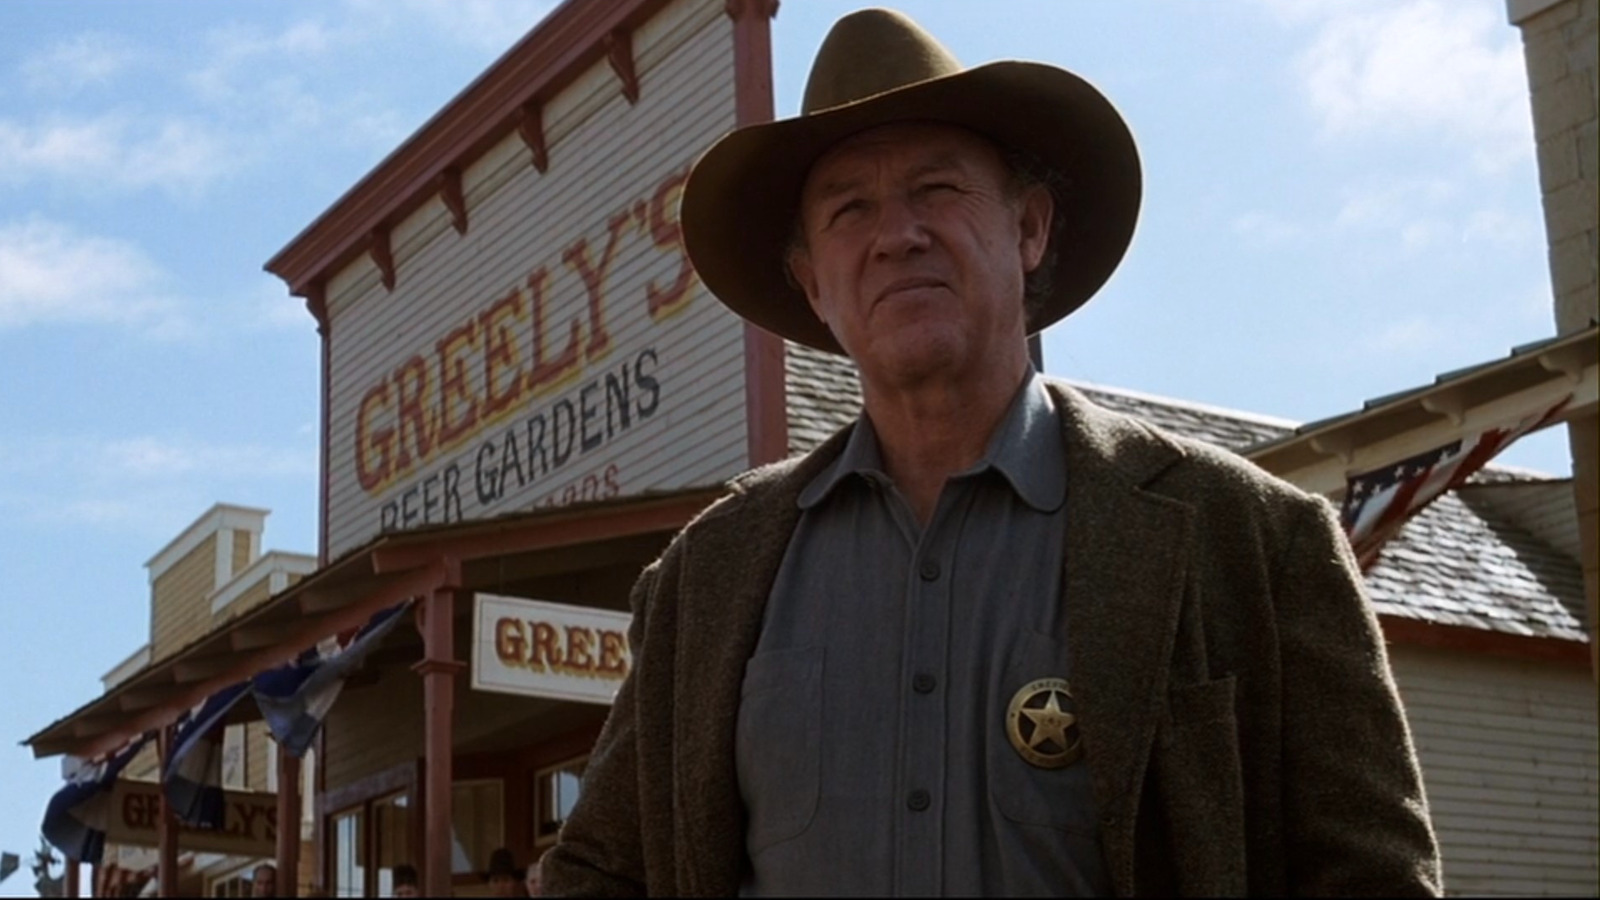Can you create a whimsical dialogue that might be happening between the sheriff and another character just out of frame? Sheriff Greeley: 'Well, if it isn’t the infamous cookie bandit, finally showing your face in town.'
Mysterious Voice (Just out of frame): 'Sheriff, I couldn’t resist Greeley's fresh-baked goodness. But today, I’m here to make a peace offering. How about a trade? My famous moonshine recipe for a dozen of those cookies?'
Sheriff Greeley: 'You drive a hard bargain, stranger. But you know what they say; you catch more flies with honey—or, in this case, cookies and moonshine.'
(Chuckling, the sheriff extends his hand for a deal, adding a humorous twist to the stern atmosphere of the scene.) 